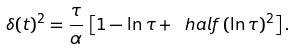<formula> <loc_0><loc_0><loc_500><loc_500>\delta ( t ) ^ { 2 } = \frac { \tau } { \alpha } \, \left [ 1 - \ln \tau + \ h a l f \, ( \ln \tau ) ^ { 2 } \right ] .</formula> 